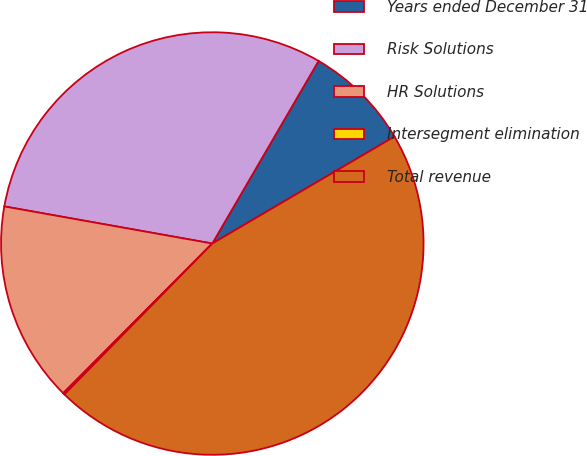Convert chart. <chart><loc_0><loc_0><loc_500><loc_500><pie_chart><fcel>Years ended December 31<fcel>Risk Solutions<fcel>HR Solutions<fcel>Intersegment elimination<fcel>Total revenue<nl><fcel>8.16%<fcel>30.58%<fcel>15.34%<fcel>0.13%<fcel>45.79%<nl></chart> 